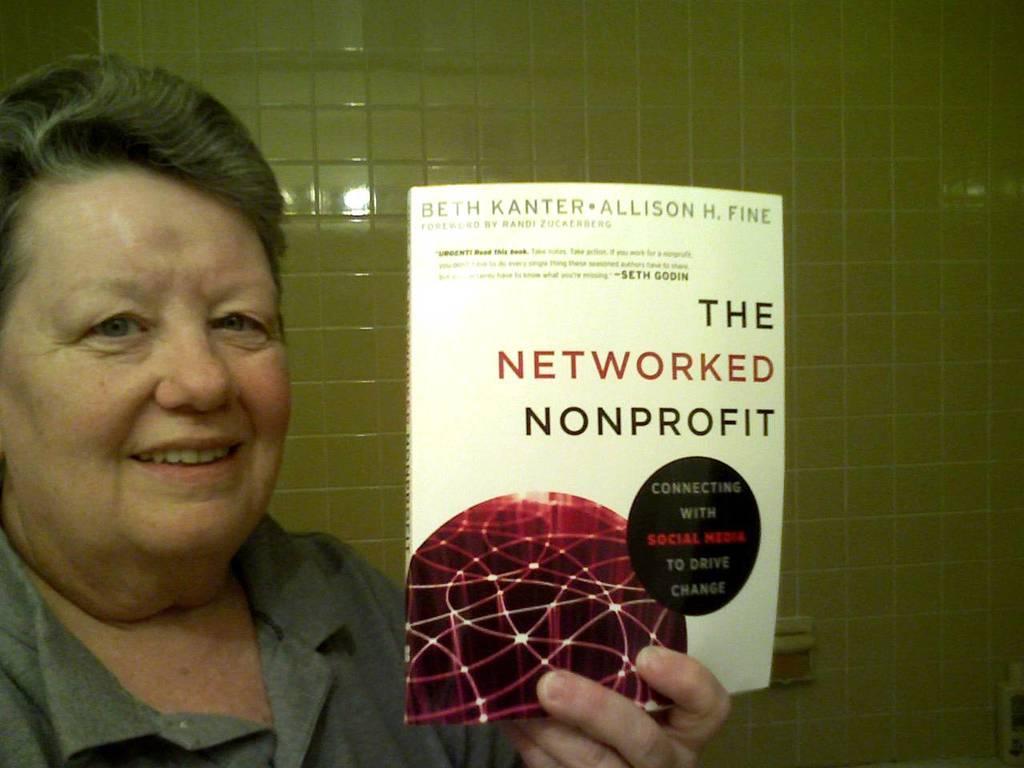Describe this image in one or two sentences. In the foreground of this picture, there is a person holding book. In the background, there is a wall. 